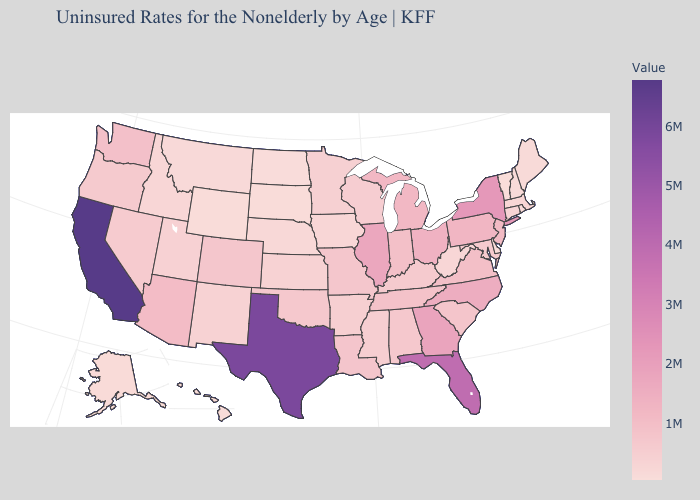Which states hav the highest value in the Northeast?
Give a very brief answer. New York. Does the map have missing data?
Quick response, please. No. Does Vermont have the lowest value in the USA?
Be succinct. Yes. Among the states that border Maine , which have the lowest value?
Short answer required. New Hampshire. Which states have the lowest value in the USA?
Keep it brief. Vermont. 